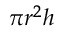Convert formula to latex. <formula><loc_0><loc_0><loc_500><loc_500>\pi r ^ { 2 } h</formula> 